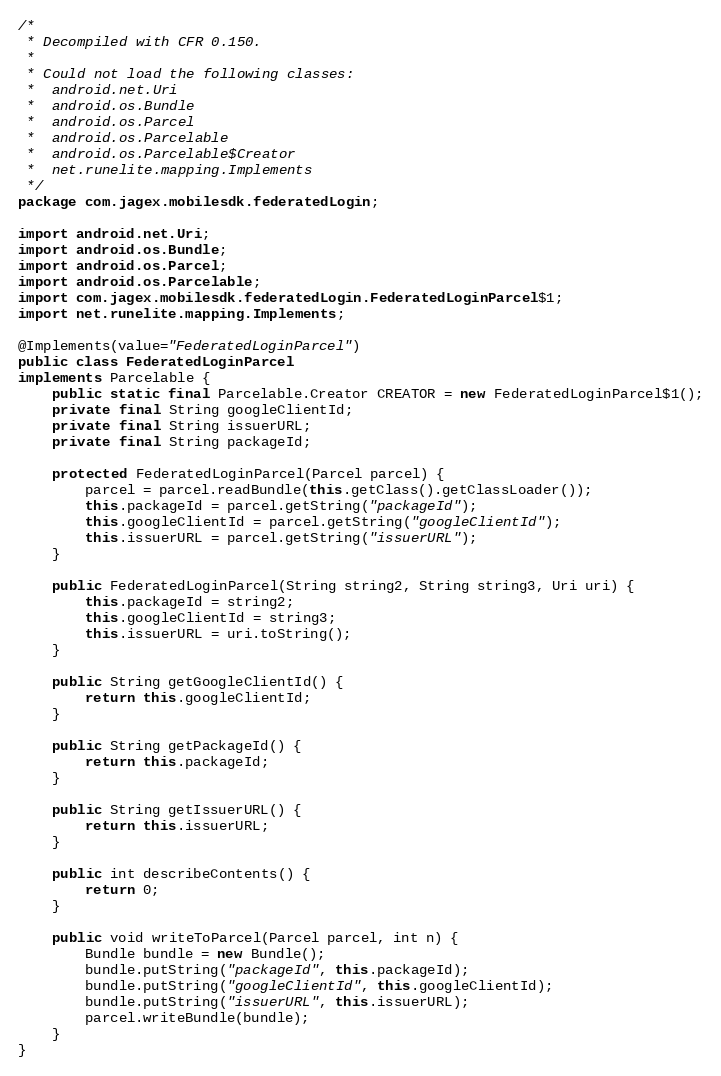Convert code to text. <code><loc_0><loc_0><loc_500><loc_500><_Java_>/*
 * Decompiled with CFR 0.150.
 * 
 * Could not load the following classes:
 *  android.net.Uri
 *  android.os.Bundle
 *  android.os.Parcel
 *  android.os.Parcelable
 *  android.os.Parcelable$Creator
 *  net.runelite.mapping.Implements
 */
package com.jagex.mobilesdk.federatedLogin;

import android.net.Uri;
import android.os.Bundle;
import android.os.Parcel;
import android.os.Parcelable;
import com.jagex.mobilesdk.federatedLogin.FederatedLoginParcel$1;
import net.runelite.mapping.Implements;

@Implements(value="FederatedLoginParcel")
public class FederatedLoginParcel
implements Parcelable {
    public static final Parcelable.Creator CREATOR = new FederatedLoginParcel$1();
    private final String googleClientId;
    private final String issuerURL;
    private final String packageId;

    protected FederatedLoginParcel(Parcel parcel) {
        parcel = parcel.readBundle(this.getClass().getClassLoader());
        this.packageId = parcel.getString("packageId");
        this.googleClientId = parcel.getString("googleClientId");
        this.issuerURL = parcel.getString("issuerURL");
    }

    public FederatedLoginParcel(String string2, String string3, Uri uri) {
        this.packageId = string2;
        this.googleClientId = string3;
        this.issuerURL = uri.toString();
    }

    public String getGoogleClientId() {
        return this.googleClientId;
    }

    public String getPackageId() {
        return this.packageId;
    }

    public String getIssuerURL() {
        return this.issuerURL;
    }

    public int describeContents() {
        return 0;
    }

    public void writeToParcel(Parcel parcel, int n) {
        Bundle bundle = new Bundle();
        bundle.putString("packageId", this.packageId);
        bundle.putString("googleClientId", this.googleClientId);
        bundle.putString("issuerURL", this.issuerURL);
        parcel.writeBundle(bundle);
    }
}

</code> 